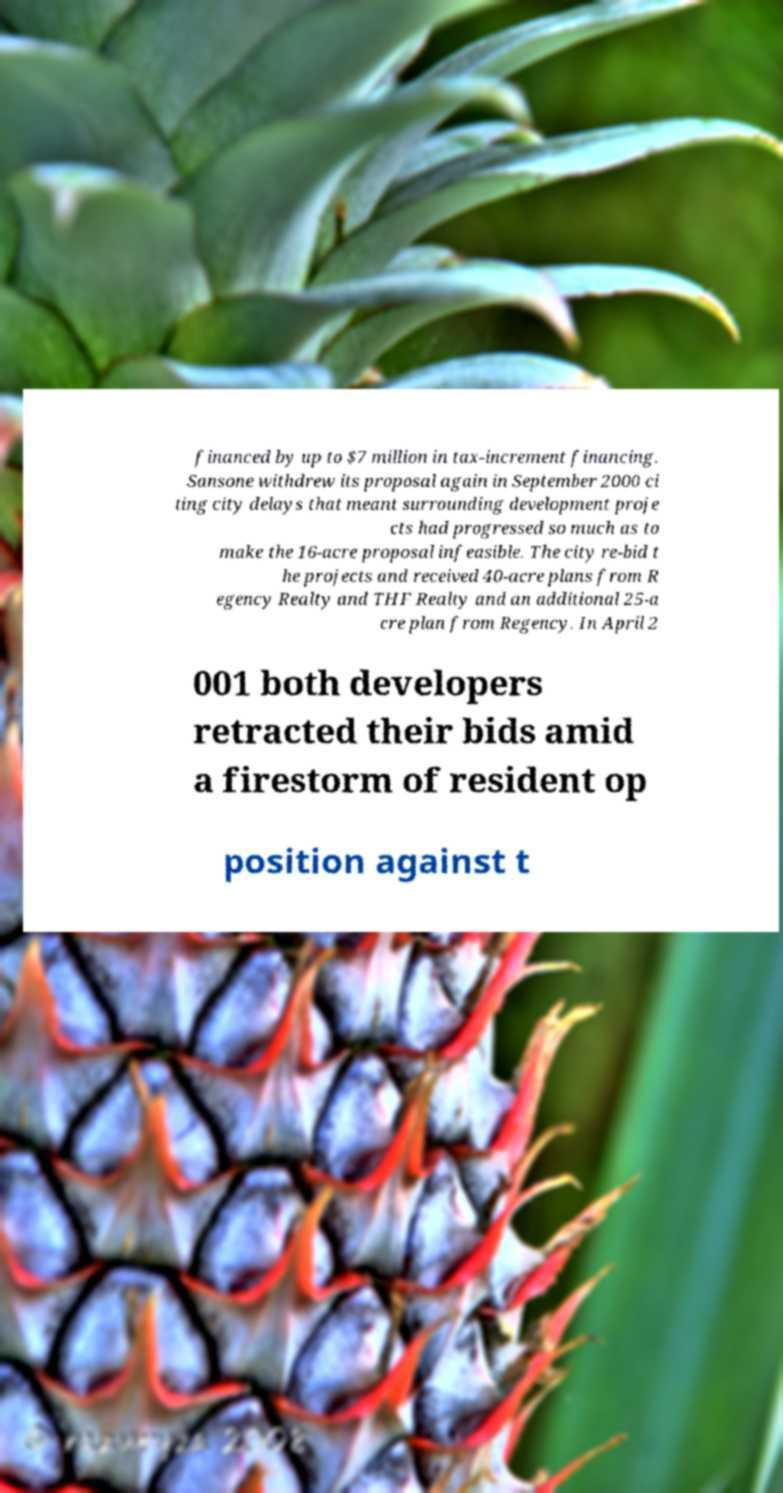Can you accurately transcribe the text from the provided image for me? financed by up to $7 million in tax-increment financing. Sansone withdrew its proposal again in September 2000 ci ting city delays that meant surrounding development proje cts had progressed so much as to make the 16-acre proposal infeasible. The city re-bid t he projects and received 40-acre plans from R egency Realty and THF Realty and an additional 25-a cre plan from Regency. In April 2 001 both developers retracted their bids amid a firestorm of resident op position against t 